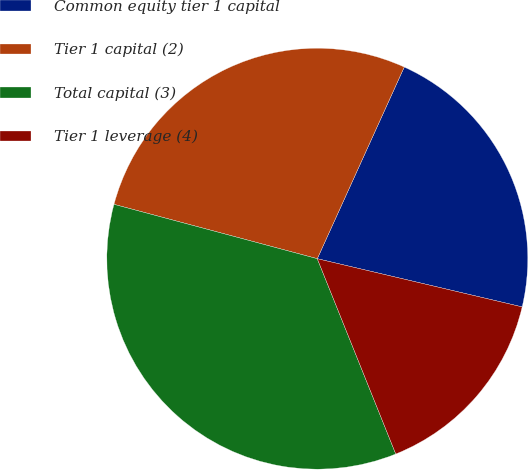<chart> <loc_0><loc_0><loc_500><loc_500><pie_chart><fcel>Common equity tier 1 capital<fcel>Tier 1 capital (2)<fcel>Total capital (3)<fcel>Tier 1 leverage (4)<nl><fcel>21.9%<fcel>27.62%<fcel>35.24%<fcel>15.24%<nl></chart> 